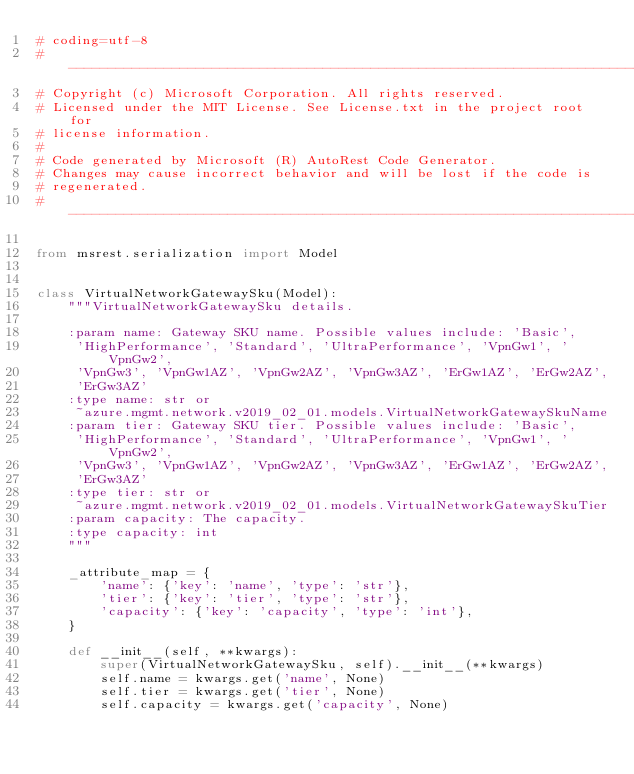<code> <loc_0><loc_0><loc_500><loc_500><_Python_># coding=utf-8
# --------------------------------------------------------------------------
# Copyright (c) Microsoft Corporation. All rights reserved.
# Licensed under the MIT License. See License.txt in the project root for
# license information.
#
# Code generated by Microsoft (R) AutoRest Code Generator.
# Changes may cause incorrect behavior and will be lost if the code is
# regenerated.
# --------------------------------------------------------------------------

from msrest.serialization import Model


class VirtualNetworkGatewaySku(Model):
    """VirtualNetworkGatewaySku details.

    :param name: Gateway SKU name. Possible values include: 'Basic',
     'HighPerformance', 'Standard', 'UltraPerformance', 'VpnGw1', 'VpnGw2',
     'VpnGw3', 'VpnGw1AZ', 'VpnGw2AZ', 'VpnGw3AZ', 'ErGw1AZ', 'ErGw2AZ',
     'ErGw3AZ'
    :type name: str or
     ~azure.mgmt.network.v2019_02_01.models.VirtualNetworkGatewaySkuName
    :param tier: Gateway SKU tier. Possible values include: 'Basic',
     'HighPerformance', 'Standard', 'UltraPerformance', 'VpnGw1', 'VpnGw2',
     'VpnGw3', 'VpnGw1AZ', 'VpnGw2AZ', 'VpnGw3AZ', 'ErGw1AZ', 'ErGw2AZ',
     'ErGw3AZ'
    :type tier: str or
     ~azure.mgmt.network.v2019_02_01.models.VirtualNetworkGatewaySkuTier
    :param capacity: The capacity.
    :type capacity: int
    """

    _attribute_map = {
        'name': {'key': 'name', 'type': 'str'},
        'tier': {'key': 'tier', 'type': 'str'},
        'capacity': {'key': 'capacity', 'type': 'int'},
    }

    def __init__(self, **kwargs):
        super(VirtualNetworkGatewaySku, self).__init__(**kwargs)
        self.name = kwargs.get('name', None)
        self.tier = kwargs.get('tier', None)
        self.capacity = kwargs.get('capacity', None)
</code> 